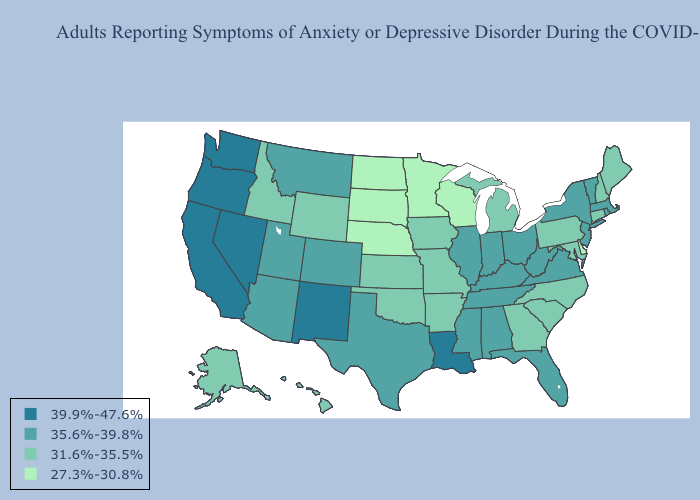Does the map have missing data?
Be succinct. No. Name the states that have a value in the range 39.9%-47.6%?
Concise answer only. California, Louisiana, Nevada, New Mexico, Oregon, Washington. Which states have the lowest value in the USA?
Keep it brief. Delaware, Minnesota, Nebraska, North Dakota, South Dakota, Wisconsin. What is the highest value in the Northeast ?
Be succinct. 35.6%-39.8%. Does Michigan have a lower value than Ohio?
Quick response, please. Yes. Does the first symbol in the legend represent the smallest category?
Give a very brief answer. No. Name the states that have a value in the range 35.6%-39.8%?
Be succinct. Alabama, Arizona, Colorado, Florida, Illinois, Indiana, Kentucky, Massachusetts, Mississippi, Montana, New Jersey, New York, Ohio, Rhode Island, Tennessee, Texas, Utah, Vermont, Virginia, West Virginia. Among the states that border Texas , which have the highest value?
Concise answer only. Louisiana, New Mexico. What is the lowest value in the West?
Write a very short answer. 31.6%-35.5%. What is the lowest value in the USA?
Give a very brief answer. 27.3%-30.8%. Name the states that have a value in the range 39.9%-47.6%?
Be succinct. California, Louisiana, Nevada, New Mexico, Oregon, Washington. Name the states that have a value in the range 31.6%-35.5%?
Give a very brief answer. Alaska, Arkansas, Connecticut, Georgia, Hawaii, Idaho, Iowa, Kansas, Maine, Maryland, Michigan, Missouri, New Hampshire, North Carolina, Oklahoma, Pennsylvania, South Carolina, Wyoming. Name the states that have a value in the range 39.9%-47.6%?
Write a very short answer. California, Louisiana, Nevada, New Mexico, Oregon, Washington. What is the value of Arizona?
Give a very brief answer. 35.6%-39.8%. What is the value of Washington?
Write a very short answer. 39.9%-47.6%. 